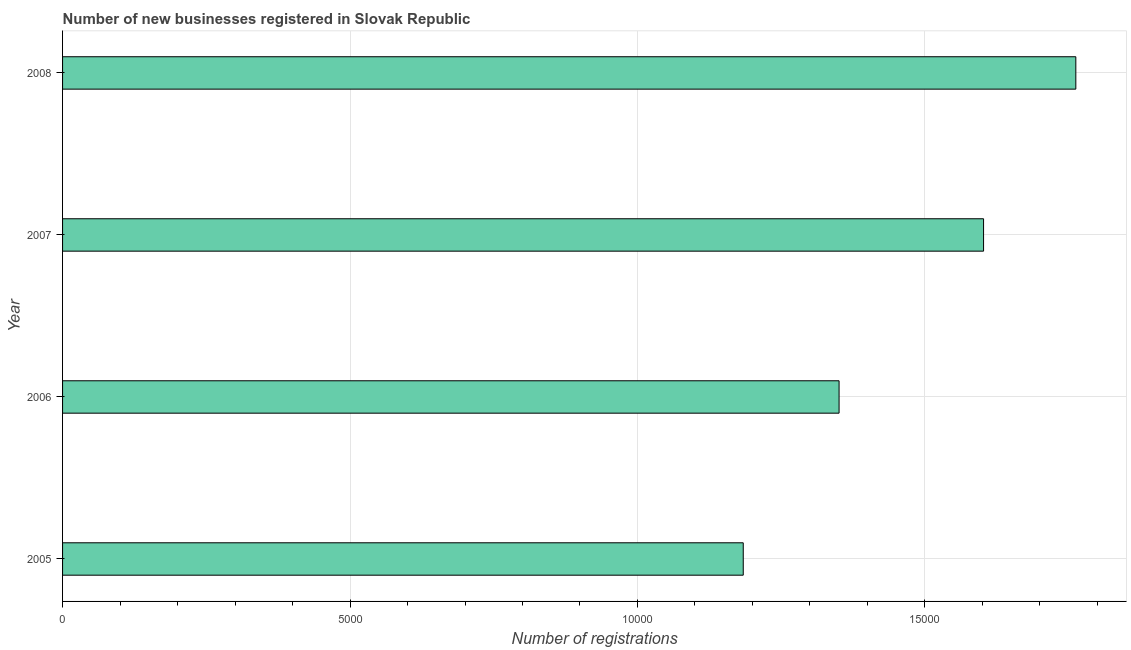What is the title of the graph?
Make the answer very short. Number of new businesses registered in Slovak Republic. What is the label or title of the X-axis?
Provide a short and direct response. Number of registrations. What is the number of new business registrations in 2007?
Give a very brief answer. 1.60e+04. Across all years, what is the maximum number of new business registrations?
Your answer should be very brief. 1.76e+04. Across all years, what is the minimum number of new business registrations?
Offer a very short reply. 1.18e+04. In which year was the number of new business registrations maximum?
Give a very brief answer. 2008. What is the sum of the number of new business registrations?
Your answer should be compact. 5.90e+04. What is the difference between the number of new business registrations in 2007 and 2008?
Provide a short and direct response. -1605. What is the average number of new business registrations per year?
Give a very brief answer. 1.47e+04. What is the median number of new business registrations?
Your answer should be very brief. 1.48e+04. In how many years, is the number of new business registrations greater than 7000 ?
Your answer should be compact. 4. What is the ratio of the number of new business registrations in 2006 to that in 2008?
Offer a very short reply. 0.77. Is the number of new business registrations in 2005 less than that in 2007?
Your answer should be very brief. Yes. Is the difference between the number of new business registrations in 2005 and 2008 greater than the difference between any two years?
Offer a terse response. Yes. What is the difference between the highest and the second highest number of new business registrations?
Your response must be concise. 1605. What is the difference between the highest and the lowest number of new business registrations?
Offer a very short reply. 5785. Are all the bars in the graph horizontal?
Give a very brief answer. Yes. How many years are there in the graph?
Give a very brief answer. 4. Are the values on the major ticks of X-axis written in scientific E-notation?
Offer a terse response. No. What is the Number of registrations in 2005?
Your answer should be compact. 1.18e+04. What is the Number of registrations in 2006?
Your answer should be compact. 1.35e+04. What is the Number of registrations in 2007?
Your answer should be compact. 1.60e+04. What is the Number of registrations in 2008?
Your response must be concise. 1.76e+04. What is the difference between the Number of registrations in 2005 and 2006?
Offer a very short reply. -1667. What is the difference between the Number of registrations in 2005 and 2007?
Your answer should be very brief. -4180. What is the difference between the Number of registrations in 2005 and 2008?
Keep it short and to the point. -5785. What is the difference between the Number of registrations in 2006 and 2007?
Keep it short and to the point. -2513. What is the difference between the Number of registrations in 2006 and 2008?
Keep it short and to the point. -4118. What is the difference between the Number of registrations in 2007 and 2008?
Your answer should be very brief. -1605. What is the ratio of the Number of registrations in 2005 to that in 2006?
Make the answer very short. 0.88. What is the ratio of the Number of registrations in 2005 to that in 2007?
Your response must be concise. 0.74. What is the ratio of the Number of registrations in 2005 to that in 2008?
Your response must be concise. 0.67. What is the ratio of the Number of registrations in 2006 to that in 2007?
Your answer should be very brief. 0.84. What is the ratio of the Number of registrations in 2006 to that in 2008?
Offer a terse response. 0.77. What is the ratio of the Number of registrations in 2007 to that in 2008?
Ensure brevity in your answer.  0.91. 